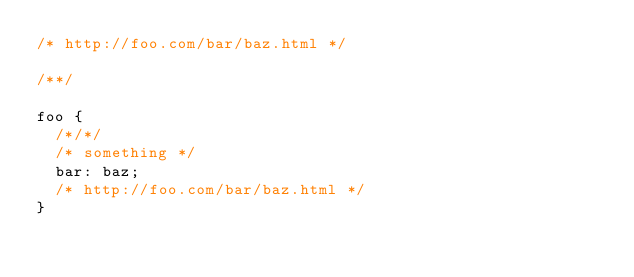<code> <loc_0><loc_0><loc_500><loc_500><_CSS_>/* http://foo.com/bar/baz.html */

/**/

foo {
  /*/*/
  /* something */
  bar: baz;
  /* http://foo.com/bar/baz.html */
}
</code> 